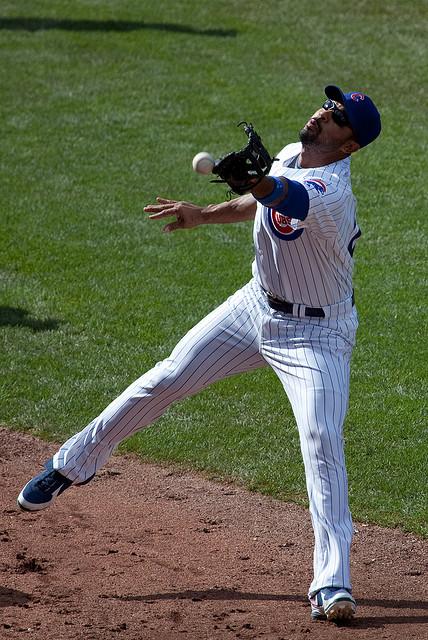Is he going to catch this ball?
Concise answer only. Yes. Is this man a professional baseball player?
Quick response, please. Yes. Between both knees there is nearly a right angle, or an angle of how many degrees?
Write a very short answer. 90. What team does he play for?
Concise answer only. Cubs. 